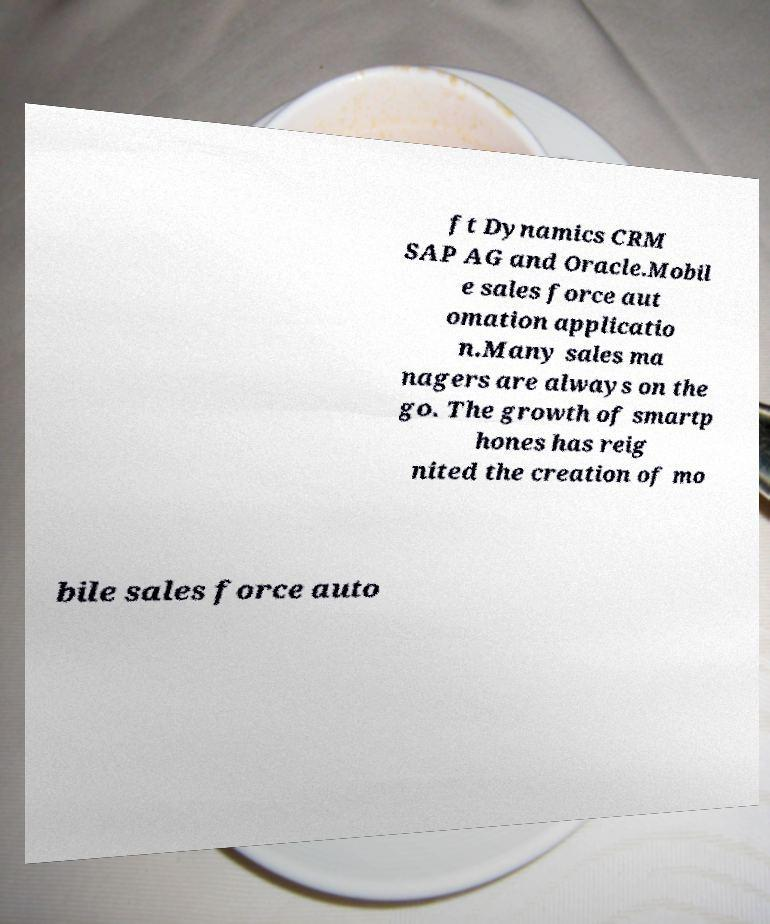Could you extract and type out the text from this image? ft Dynamics CRM SAP AG and Oracle.Mobil e sales force aut omation applicatio n.Many sales ma nagers are always on the go. The growth of smartp hones has reig nited the creation of mo bile sales force auto 